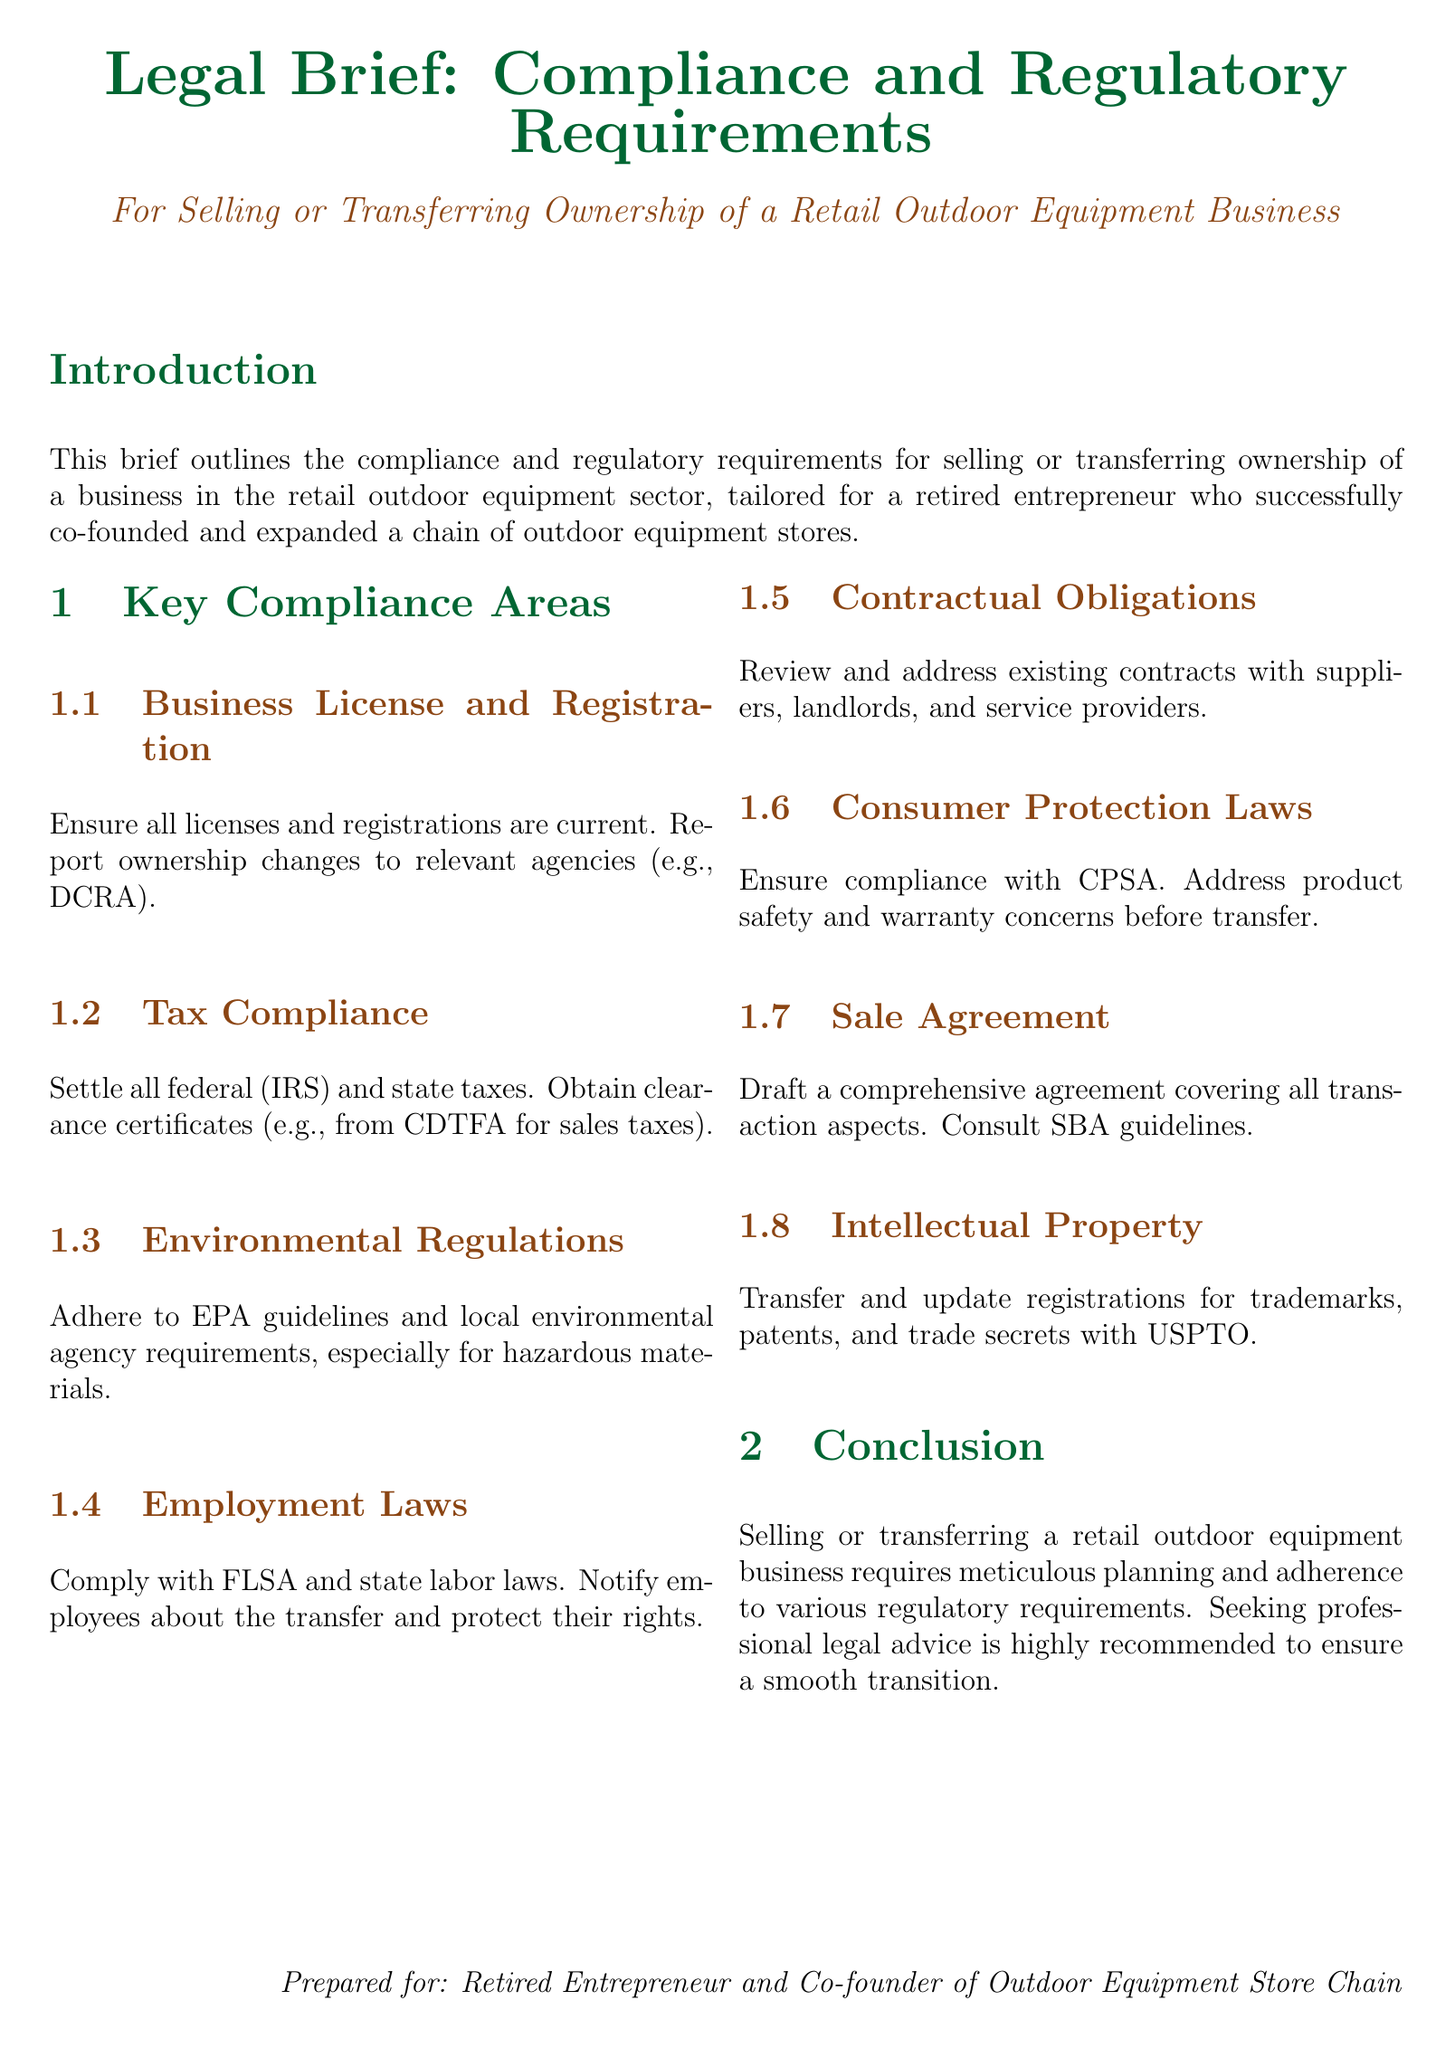What is the main topic of the document? The main topic is outlined in the title and introduction, which specify that it's about compliance and regulatory requirements for selling or transferring ownership of a retail outdoor equipment business.
Answer: Compliance and regulatory requirements Which law is referenced for tax compliance? The document references IRS for federal tax compliance.
Answer: IRS What agency must be notified about ownership changes? The document mentions the DCRA as the relevant agency to report ownership changes.
Answer: DCRA What regulation must be adhered to regarding hazardous materials? The document states adherence to EPA guidelines and local regulations concerning hazardous materials.
Answer: EPA guidelines Which act is mentioned in relation to employment laws? The Fair Labor Standards Act (FLSA) is specified in the employment laws section.
Answer: FLSA What type of certificate must be obtained for sales taxes? The document specifies obtaining clearance certificates from the CDTFA for sales taxes.
Answer: CDTFA What should be drafted to cover all transaction aspects? The document advises drafting a comprehensive sale agreement for the transaction.
Answer: Sale agreement Which intellectual property office is mentioned for registrations? The USPTO is identified as the office for transferring and updating registrations for intellectual property.
Answer: USPTO What is highly recommended before transferring ownership of the business? The conclusion emphasizes the need for professional legal advice to ensure a smooth transition.
Answer: Professional legal advice 